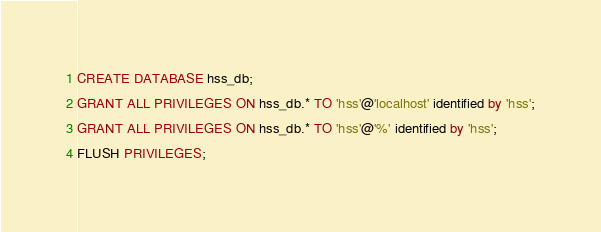Convert code to text. <code><loc_0><loc_0><loc_500><loc_500><_SQL_>CREATE DATABASE hss_db;
GRANT ALL PRIVILEGES ON hss_db.* TO 'hss'@'localhost' identified by 'hss';
GRANT ALL PRIVILEGES ON hss_db.* TO 'hss'@'%' identified by 'hss';
FLUSH PRIVILEGES;
</code> 